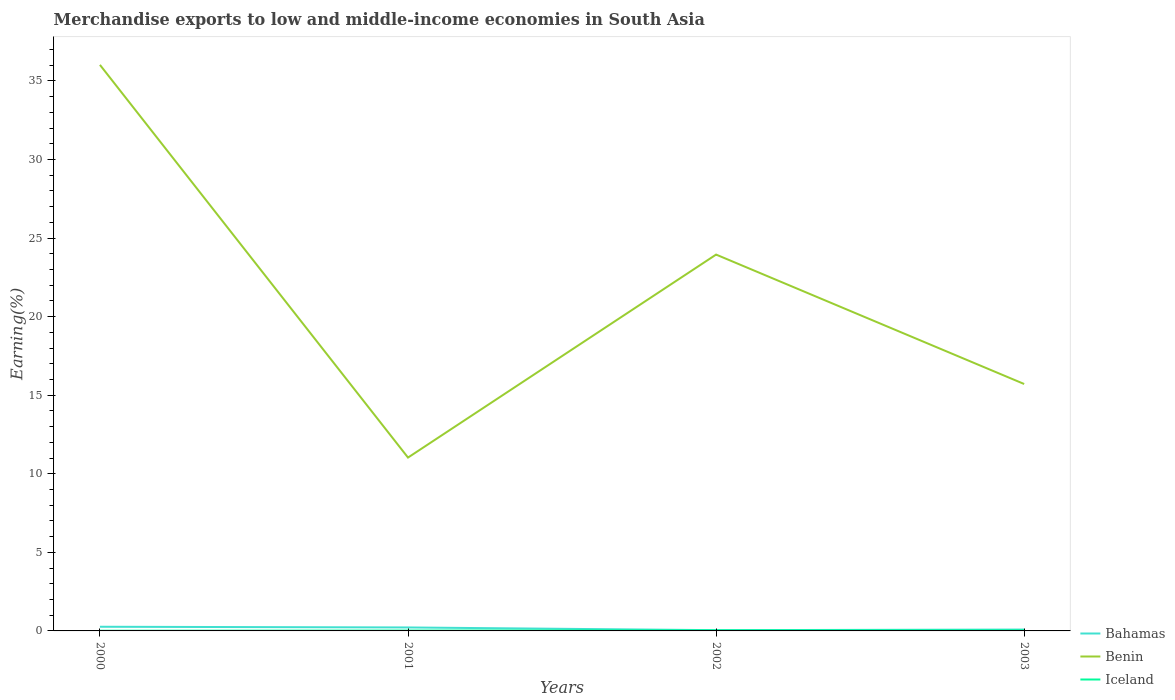How many different coloured lines are there?
Provide a short and direct response. 3. Does the line corresponding to Bahamas intersect with the line corresponding to Iceland?
Ensure brevity in your answer.  No. Across all years, what is the maximum percentage of amount earned from merchandise exports in Benin?
Provide a short and direct response. 11.03. In which year was the percentage of amount earned from merchandise exports in Iceland maximum?
Ensure brevity in your answer.  2000. What is the total percentage of amount earned from merchandise exports in Benin in the graph?
Keep it short and to the point. 8.24. What is the difference between the highest and the second highest percentage of amount earned from merchandise exports in Bahamas?
Provide a succinct answer. 0.22. Is the percentage of amount earned from merchandise exports in Iceland strictly greater than the percentage of amount earned from merchandise exports in Benin over the years?
Ensure brevity in your answer.  Yes. How many lines are there?
Keep it short and to the point. 3. How many years are there in the graph?
Give a very brief answer. 4. What is the difference between two consecutive major ticks on the Y-axis?
Give a very brief answer. 5. Are the values on the major ticks of Y-axis written in scientific E-notation?
Offer a terse response. No. Does the graph contain any zero values?
Offer a terse response. No. Does the graph contain grids?
Provide a short and direct response. No. Where does the legend appear in the graph?
Offer a terse response. Bottom right. What is the title of the graph?
Keep it short and to the point. Merchandise exports to low and middle-income economies in South Asia. What is the label or title of the Y-axis?
Keep it short and to the point. Earning(%). What is the Earning(%) of Bahamas in 2000?
Offer a terse response. 0.27. What is the Earning(%) of Benin in 2000?
Offer a terse response. 36.02. What is the Earning(%) in Iceland in 2000?
Make the answer very short. 0.01. What is the Earning(%) of Bahamas in 2001?
Offer a very short reply. 0.22. What is the Earning(%) in Benin in 2001?
Offer a terse response. 11.03. What is the Earning(%) of Iceland in 2001?
Your answer should be compact. 0.02. What is the Earning(%) in Bahamas in 2002?
Provide a succinct answer. 0.05. What is the Earning(%) of Benin in 2002?
Offer a terse response. 23.95. What is the Earning(%) in Iceland in 2002?
Ensure brevity in your answer.  0.03. What is the Earning(%) of Bahamas in 2003?
Your response must be concise. 0.09. What is the Earning(%) of Benin in 2003?
Offer a terse response. 15.71. What is the Earning(%) in Iceland in 2003?
Offer a very short reply. 0.03. Across all years, what is the maximum Earning(%) in Bahamas?
Offer a very short reply. 0.27. Across all years, what is the maximum Earning(%) of Benin?
Your answer should be compact. 36.02. Across all years, what is the maximum Earning(%) of Iceland?
Provide a succinct answer. 0.03. Across all years, what is the minimum Earning(%) in Bahamas?
Provide a succinct answer. 0.05. Across all years, what is the minimum Earning(%) of Benin?
Your response must be concise. 11.03. Across all years, what is the minimum Earning(%) in Iceland?
Offer a very short reply. 0.01. What is the total Earning(%) of Bahamas in the graph?
Offer a terse response. 0.62. What is the total Earning(%) in Benin in the graph?
Give a very brief answer. 86.71. What is the total Earning(%) in Iceland in the graph?
Your answer should be very brief. 0.1. What is the difference between the Earning(%) in Bahamas in 2000 and that in 2001?
Provide a succinct answer. 0.04. What is the difference between the Earning(%) of Benin in 2000 and that in 2001?
Provide a short and direct response. 24.99. What is the difference between the Earning(%) of Iceland in 2000 and that in 2001?
Your response must be concise. -0.01. What is the difference between the Earning(%) of Bahamas in 2000 and that in 2002?
Your answer should be compact. 0.22. What is the difference between the Earning(%) in Benin in 2000 and that in 2002?
Keep it short and to the point. 12.07. What is the difference between the Earning(%) of Iceland in 2000 and that in 2002?
Offer a very short reply. -0.02. What is the difference between the Earning(%) in Bahamas in 2000 and that in 2003?
Offer a terse response. 0.18. What is the difference between the Earning(%) of Benin in 2000 and that in 2003?
Your answer should be compact. 20.31. What is the difference between the Earning(%) in Iceland in 2000 and that in 2003?
Provide a short and direct response. -0.02. What is the difference between the Earning(%) of Bahamas in 2001 and that in 2002?
Give a very brief answer. 0.17. What is the difference between the Earning(%) in Benin in 2001 and that in 2002?
Your answer should be compact. -12.92. What is the difference between the Earning(%) in Iceland in 2001 and that in 2002?
Make the answer very short. -0.01. What is the difference between the Earning(%) in Bahamas in 2001 and that in 2003?
Make the answer very short. 0.13. What is the difference between the Earning(%) in Benin in 2001 and that in 2003?
Make the answer very short. -4.68. What is the difference between the Earning(%) in Iceland in 2001 and that in 2003?
Offer a terse response. -0.01. What is the difference between the Earning(%) of Bahamas in 2002 and that in 2003?
Keep it short and to the point. -0.04. What is the difference between the Earning(%) of Benin in 2002 and that in 2003?
Your answer should be very brief. 8.24. What is the difference between the Earning(%) in Iceland in 2002 and that in 2003?
Offer a very short reply. 0. What is the difference between the Earning(%) of Bahamas in 2000 and the Earning(%) of Benin in 2001?
Keep it short and to the point. -10.77. What is the difference between the Earning(%) in Bahamas in 2000 and the Earning(%) in Iceland in 2001?
Give a very brief answer. 0.24. What is the difference between the Earning(%) in Benin in 2000 and the Earning(%) in Iceland in 2001?
Your response must be concise. 36. What is the difference between the Earning(%) in Bahamas in 2000 and the Earning(%) in Benin in 2002?
Ensure brevity in your answer.  -23.68. What is the difference between the Earning(%) in Bahamas in 2000 and the Earning(%) in Iceland in 2002?
Keep it short and to the point. 0.23. What is the difference between the Earning(%) in Benin in 2000 and the Earning(%) in Iceland in 2002?
Keep it short and to the point. 35.99. What is the difference between the Earning(%) of Bahamas in 2000 and the Earning(%) of Benin in 2003?
Provide a short and direct response. -15.45. What is the difference between the Earning(%) in Bahamas in 2000 and the Earning(%) in Iceland in 2003?
Offer a very short reply. 0.23. What is the difference between the Earning(%) of Benin in 2000 and the Earning(%) of Iceland in 2003?
Ensure brevity in your answer.  35.99. What is the difference between the Earning(%) of Bahamas in 2001 and the Earning(%) of Benin in 2002?
Offer a very short reply. -23.73. What is the difference between the Earning(%) of Bahamas in 2001 and the Earning(%) of Iceland in 2002?
Your response must be concise. 0.19. What is the difference between the Earning(%) of Benin in 2001 and the Earning(%) of Iceland in 2002?
Keep it short and to the point. 11. What is the difference between the Earning(%) of Bahamas in 2001 and the Earning(%) of Benin in 2003?
Your answer should be compact. -15.49. What is the difference between the Earning(%) of Bahamas in 2001 and the Earning(%) of Iceland in 2003?
Make the answer very short. 0.19. What is the difference between the Earning(%) in Benin in 2001 and the Earning(%) in Iceland in 2003?
Ensure brevity in your answer.  11. What is the difference between the Earning(%) in Bahamas in 2002 and the Earning(%) in Benin in 2003?
Keep it short and to the point. -15.66. What is the difference between the Earning(%) in Bahamas in 2002 and the Earning(%) in Iceland in 2003?
Make the answer very short. 0.02. What is the difference between the Earning(%) of Benin in 2002 and the Earning(%) of Iceland in 2003?
Offer a very short reply. 23.92. What is the average Earning(%) in Bahamas per year?
Your response must be concise. 0.16. What is the average Earning(%) in Benin per year?
Offer a terse response. 21.68. What is the average Earning(%) in Iceland per year?
Keep it short and to the point. 0.03. In the year 2000, what is the difference between the Earning(%) in Bahamas and Earning(%) in Benin?
Offer a very short reply. -35.76. In the year 2000, what is the difference between the Earning(%) of Bahamas and Earning(%) of Iceland?
Provide a succinct answer. 0.25. In the year 2000, what is the difference between the Earning(%) of Benin and Earning(%) of Iceland?
Offer a very short reply. 36.01. In the year 2001, what is the difference between the Earning(%) of Bahamas and Earning(%) of Benin?
Provide a short and direct response. -10.81. In the year 2001, what is the difference between the Earning(%) of Bahamas and Earning(%) of Iceland?
Ensure brevity in your answer.  0.2. In the year 2001, what is the difference between the Earning(%) in Benin and Earning(%) in Iceland?
Offer a very short reply. 11.01. In the year 2002, what is the difference between the Earning(%) in Bahamas and Earning(%) in Benin?
Offer a terse response. -23.9. In the year 2002, what is the difference between the Earning(%) of Bahamas and Earning(%) of Iceland?
Provide a succinct answer. 0.01. In the year 2002, what is the difference between the Earning(%) in Benin and Earning(%) in Iceland?
Keep it short and to the point. 23.91. In the year 2003, what is the difference between the Earning(%) in Bahamas and Earning(%) in Benin?
Your answer should be compact. -15.63. In the year 2003, what is the difference between the Earning(%) in Bahamas and Earning(%) in Iceland?
Ensure brevity in your answer.  0.06. In the year 2003, what is the difference between the Earning(%) of Benin and Earning(%) of Iceland?
Provide a succinct answer. 15.68. What is the ratio of the Earning(%) in Bahamas in 2000 to that in 2001?
Make the answer very short. 1.2. What is the ratio of the Earning(%) in Benin in 2000 to that in 2001?
Keep it short and to the point. 3.27. What is the ratio of the Earning(%) in Iceland in 2000 to that in 2001?
Offer a very short reply. 0.48. What is the ratio of the Earning(%) in Bahamas in 2000 to that in 2002?
Your response must be concise. 5.54. What is the ratio of the Earning(%) in Benin in 2000 to that in 2002?
Your answer should be compact. 1.5. What is the ratio of the Earning(%) in Iceland in 2000 to that in 2002?
Give a very brief answer. 0.33. What is the ratio of the Earning(%) in Bahamas in 2000 to that in 2003?
Keep it short and to the point. 3.03. What is the ratio of the Earning(%) of Benin in 2000 to that in 2003?
Offer a terse response. 2.29. What is the ratio of the Earning(%) of Iceland in 2000 to that in 2003?
Ensure brevity in your answer.  0.36. What is the ratio of the Earning(%) of Bahamas in 2001 to that in 2002?
Offer a very short reply. 4.62. What is the ratio of the Earning(%) in Benin in 2001 to that in 2002?
Make the answer very short. 0.46. What is the ratio of the Earning(%) in Iceland in 2001 to that in 2002?
Give a very brief answer. 0.69. What is the ratio of the Earning(%) in Bahamas in 2001 to that in 2003?
Your answer should be compact. 2.52. What is the ratio of the Earning(%) of Benin in 2001 to that in 2003?
Make the answer very short. 0.7. What is the ratio of the Earning(%) in Iceland in 2001 to that in 2003?
Provide a short and direct response. 0.75. What is the ratio of the Earning(%) in Bahamas in 2002 to that in 2003?
Keep it short and to the point. 0.55. What is the ratio of the Earning(%) in Benin in 2002 to that in 2003?
Provide a short and direct response. 1.52. What is the ratio of the Earning(%) in Iceland in 2002 to that in 2003?
Offer a terse response. 1.08. What is the difference between the highest and the second highest Earning(%) in Bahamas?
Your response must be concise. 0.04. What is the difference between the highest and the second highest Earning(%) in Benin?
Provide a succinct answer. 12.07. What is the difference between the highest and the second highest Earning(%) of Iceland?
Offer a terse response. 0. What is the difference between the highest and the lowest Earning(%) of Bahamas?
Provide a short and direct response. 0.22. What is the difference between the highest and the lowest Earning(%) of Benin?
Make the answer very short. 24.99. What is the difference between the highest and the lowest Earning(%) of Iceland?
Your response must be concise. 0.02. 